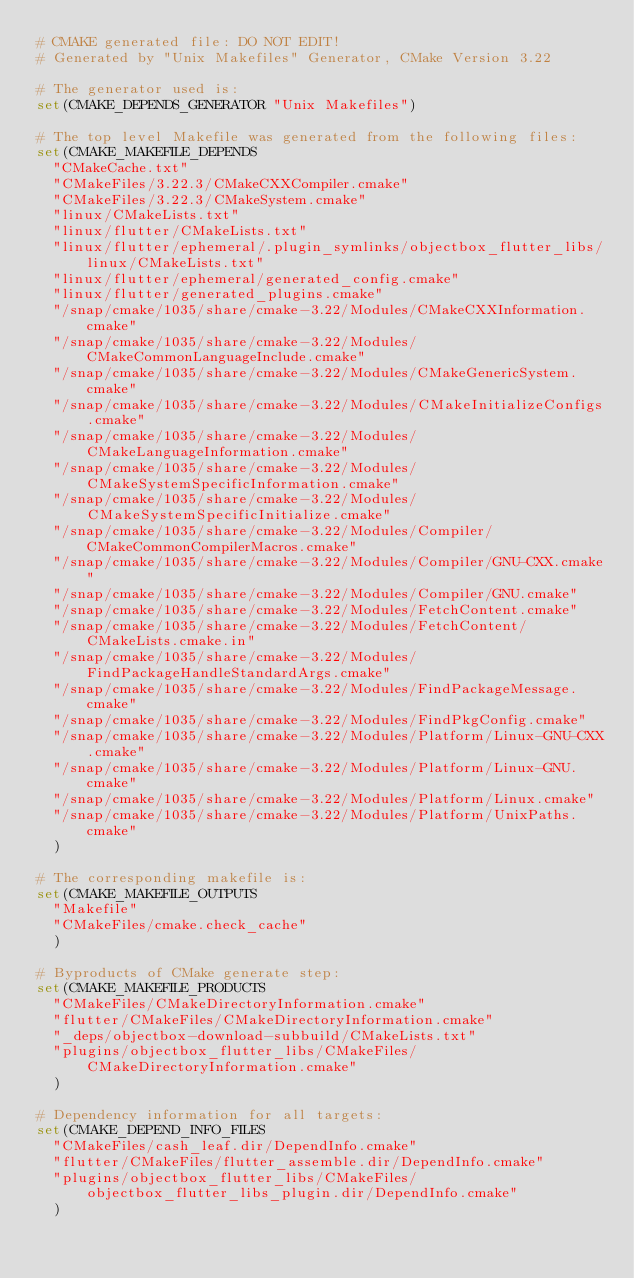Convert code to text. <code><loc_0><loc_0><loc_500><loc_500><_CMake_># CMAKE generated file: DO NOT EDIT!
# Generated by "Unix Makefiles" Generator, CMake Version 3.22

# The generator used is:
set(CMAKE_DEPENDS_GENERATOR "Unix Makefiles")

# The top level Makefile was generated from the following files:
set(CMAKE_MAKEFILE_DEPENDS
  "CMakeCache.txt"
  "CMakeFiles/3.22.3/CMakeCXXCompiler.cmake"
  "CMakeFiles/3.22.3/CMakeSystem.cmake"
  "linux/CMakeLists.txt"
  "linux/flutter/CMakeLists.txt"
  "linux/flutter/ephemeral/.plugin_symlinks/objectbox_flutter_libs/linux/CMakeLists.txt"
  "linux/flutter/ephemeral/generated_config.cmake"
  "linux/flutter/generated_plugins.cmake"
  "/snap/cmake/1035/share/cmake-3.22/Modules/CMakeCXXInformation.cmake"
  "/snap/cmake/1035/share/cmake-3.22/Modules/CMakeCommonLanguageInclude.cmake"
  "/snap/cmake/1035/share/cmake-3.22/Modules/CMakeGenericSystem.cmake"
  "/snap/cmake/1035/share/cmake-3.22/Modules/CMakeInitializeConfigs.cmake"
  "/snap/cmake/1035/share/cmake-3.22/Modules/CMakeLanguageInformation.cmake"
  "/snap/cmake/1035/share/cmake-3.22/Modules/CMakeSystemSpecificInformation.cmake"
  "/snap/cmake/1035/share/cmake-3.22/Modules/CMakeSystemSpecificInitialize.cmake"
  "/snap/cmake/1035/share/cmake-3.22/Modules/Compiler/CMakeCommonCompilerMacros.cmake"
  "/snap/cmake/1035/share/cmake-3.22/Modules/Compiler/GNU-CXX.cmake"
  "/snap/cmake/1035/share/cmake-3.22/Modules/Compiler/GNU.cmake"
  "/snap/cmake/1035/share/cmake-3.22/Modules/FetchContent.cmake"
  "/snap/cmake/1035/share/cmake-3.22/Modules/FetchContent/CMakeLists.cmake.in"
  "/snap/cmake/1035/share/cmake-3.22/Modules/FindPackageHandleStandardArgs.cmake"
  "/snap/cmake/1035/share/cmake-3.22/Modules/FindPackageMessage.cmake"
  "/snap/cmake/1035/share/cmake-3.22/Modules/FindPkgConfig.cmake"
  "/snap/cmake/1035/share/cmake-3.22/Modules/Platform/Linux-GNU-CXX.cmake"
  "/snap/cmake/1035/share/cmake-3.22/Modules/Platform/Linux-GNU.cmake"
  "/snap/cmake/1035/share/cmake-3.22/Modules/Platform/Linux.cmake"
  "/snap/cmake/1035/share/cmake-3.22/Modules/Platform/UnixPaths.cmake"
  )

# The corresponding makefile is:
set(CMAKE_MAKEFILE_OUTPUTS
  "Makefile"
  "CMakeFiles/cmake.check_cache"
  )

# Byproducts of CMake generate step:
set(CMAKE_MAKEFILE_PRODUCTS
  "CMakeFiles/CMakeDirectoryInformation.cmake"
  "flutter/CMakeFiles/CMakeDirectoryInformation.cmake"
  "_deps/objectbox-download-subbuild/CMakeLists.txt"
  "plugins/objectbox_flutter_libs/CMakeFiles/CMakeDirectoryInformation.cmake"
  )

# Dependency information for all targets:
set(CMAKE_DEPEND_INFO_FILES
  "CMakeFiles/cash_leaf.dir/DependInfo.cmake"
  "flutter/CMakeFiles/flutter_assemble.dir/DependInfo.cmake"
  "plugins/objectbox_flutter_libs/CMakeFiles/objectbox_flutter_libs_plugin.dir/DependInfo.cmake"
  )
</code> 